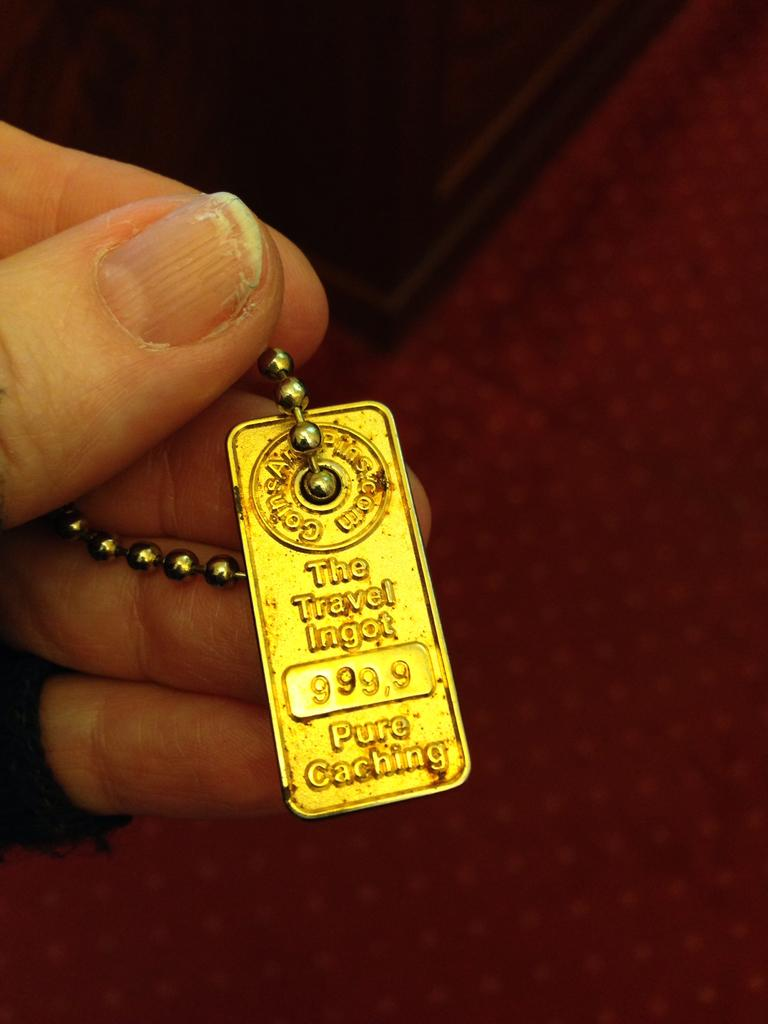What is present in the image? There is a person in the image. What is the person holding in their hand? The person is holding a keychain in their hand. What is featured on the keychain? There is text on the keychain. What type of trains can be seen in the image? There are no trains present in the image. Is the person in the image a doctor? The image does not provide any information about the person's profession, so it cannot be determined if they are a doctor. What month is depicted on the calendar in the image? There is no calendar present in the image. 